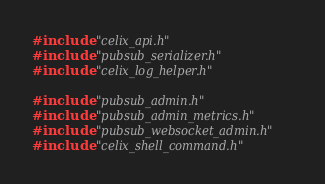<code> <loc_0><loc_0><loc_500><loc_500><_C_>
#include "celix_api.h"
#include "pubsub_serializer.h"
#include "celix_log_helper.h"

#include "pubsub_admin.h"
#include "pubsub_admin_metrics.h"
#include "pubsub_websocket_admin.h"
#include "celix_shell_command.h"
</code> 